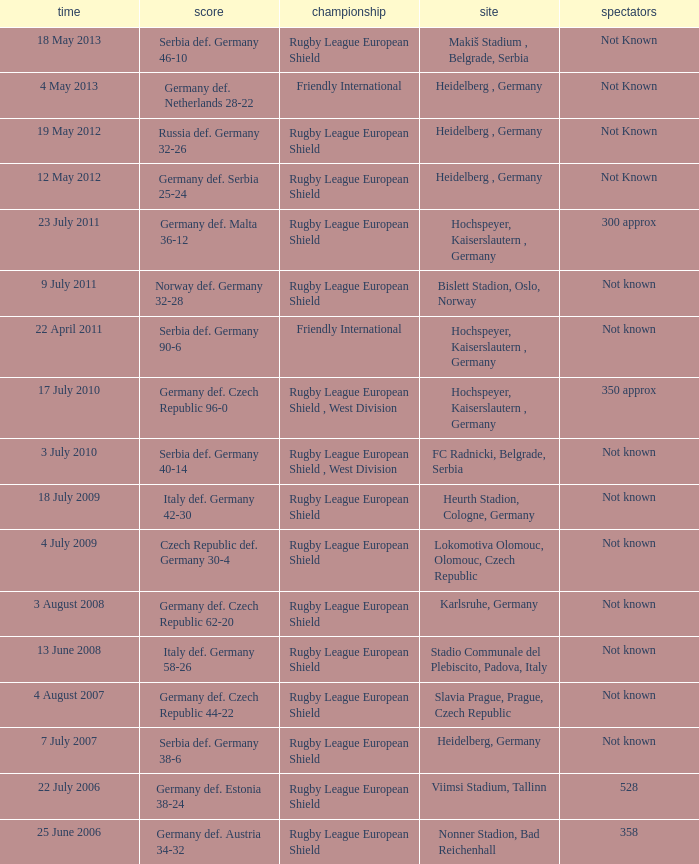For the game with 528 attendance, what was the result? Germany def. Estonia 38-24. 